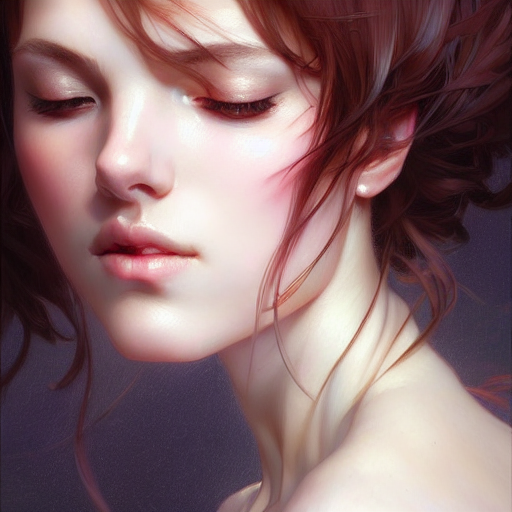Can you comment on the lighting effects in this image? The lighting in this image is soft and appears to be diffused, enveloping the subject's face in a warm glow that accentuates the complexion while creating depth through gentle shadows. 